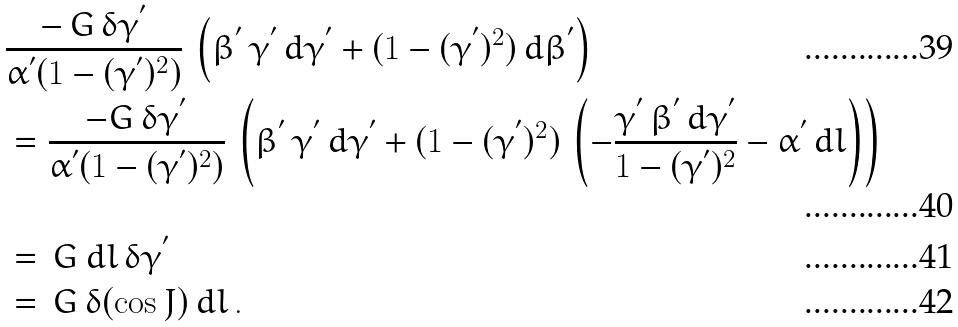Convert formula to latex. <formula><loc_0><loc_0><loc_500><loc_500>& \frac { - \, G \, { \delta } { \gamma } ^ { ^ { \prime } } } { { \alpha } ^ { ^ { \prime } } ( 1 - ( { \gamma } ^ { ^ { \prime } } ) ^ { 2 } ) } \, \left ( { \beta } ^ { ^ { \prime } } \, { \gamma } ^ { ^ { \prime } } \, d { \gamma } ^ { ^ { \prime } } + ( 1 - ( { \gamma } ^ { ^ { \prime } } ) ^ { 2 } ) \, d { \beta } ^ { ^ { \prime } } \right ) \\ & = \frac { - G \, { \delta } { \gamma } ^ { ^ { \prime } } } { { \alpha } ^ { ^ { \prime } } ( 1 - ( { \gamma } ^ { ^ { \prime } } ) ^ { 2 } ) } \, \left ( { \beta } ^ { ^ { \prime } } \, { \gamma } ^ { ^ { \prime } } \, d { \gamma } ^ { ^ { \prime } } + ( 1 - ( { \gamma } ^ { ^ { \prime } } ) ^ { 2 } ) \, \left ( - \frac { { \gamma } ^ { ^ { \prime } } \, { \beta } ^ { ^ { \prime } } \, d { \gamma } ^ { ^ { \prime } } } { 1 - ( { \gamma } ^ { ^ { \prime } } ) ^ { 2 } } - { \alpha } ^ { ^ { \prime } } \, d l \right ) \right ) \\ & = \, G \, d l \, { \delta } { \gamma } ^ { ^ { \prime } } \\ & = \, G \, { \delta } ( \cos J ) \, d l \, .</formula> 